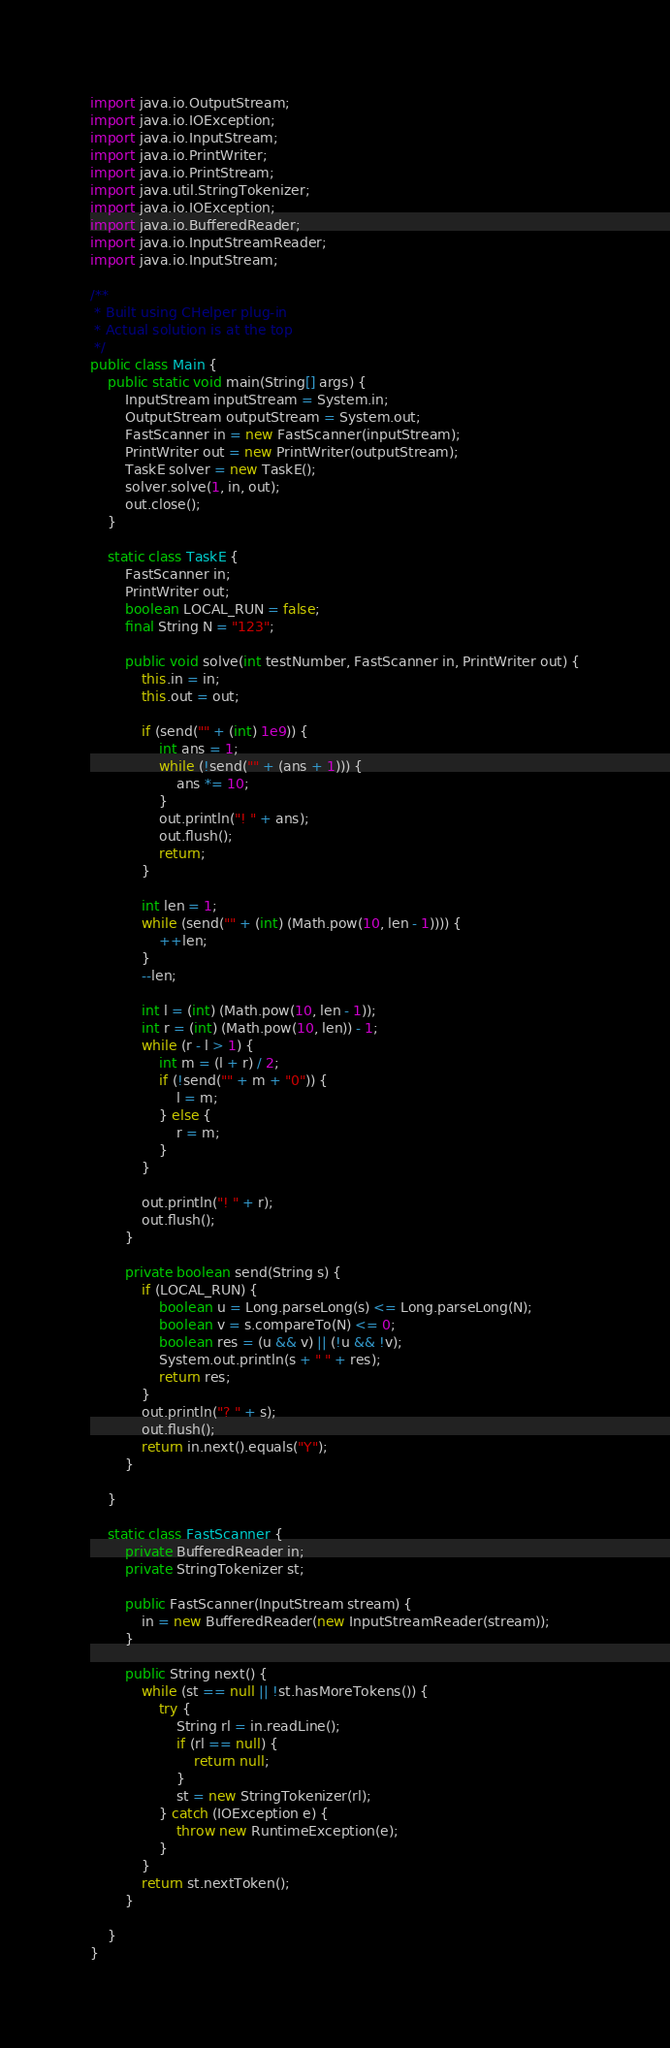<code> <loc_0><loc_0><loc_500><loc_500><_Java_>import java.io.OutputStream;
import java.io.IOException;
import java.io.InputStream;
import java.io.PrintWriter;
import java.io.PrintStream;
import java.util.StringTokenizer;
import java.io.IOException;
import java.io.BufferedReader;
import java.io.InputStreamReader;
import java.io.InputStream;

/**
 * Built using CHelper plug-in
 * Actual solution is at the top
 */
public class Main {
	public static void main(String[] args) {
		InputStream inputStream = System.in;
		OutputStream outputStream = System.out;
		FastScanner in = new FastScanner(inputStream);
		PrintWriter out = new PrintWriter(outputStream);
		TaskE solver = new TaskE();
		solver.solve(1, in, out);
		out.close();
	}

	static class TaskE {
		FastScanner in;
		PrintWriter out;
		boolean LOCAL_RUN = false;
		final String N = "123";

		public void solve(int testNumber, FastScanner in, PrintWriter out) {
			this.in = in;
			this.out = out;

			if (send("" + (int) 1e9)) {
				int ans = 1;
				while (!send("" + (ans + 1))) {
					ans *= 10;
				}
				out.println("! " + ans);
				out.flush();
				return;
			}

			int len = 1;
			while (send("" + (int) (Math.pow(10, len - 1)))) {
				++len;
			}
			--len;

			int l = (int) (Math.pow(10, len - 1));
			int r = (int) (Math.pow(10, len)) - 1;
			while (r - l > 1) {
				int m = (l + r) / 2;
				if (!send("" + m + "0")) {
					l = m;
				} else {
					r = m;
				}
			}

			out.println("! " + r);
			out.flush();
		}

		private boolean send(String s) {
			if (LOCAL_RUN) {
				boolean u = Long.parseLong(s) <= Long.parseLong(N);
				boolean v = s.compareTo(N) <= 0;
				boolean res = (u && v) || (!u && !v);
				System.out.println(s + " " + res);
				return res;
			}
			out.println("? " + s);
			out.flush();
			return in.next().equals("Y");
		}

	}

	static class FastScanner {
		private BufferedReader in;
		private StringTokenizer st;

		public FastScanner(InputStream stream) {
			in = new BufferedReader(new InputStreamReader(stream));
		}

		public String next() {
			while (st == null || !st.hasMoreTokens()) {
				try {
					String rl = in.readLine();
					if (rl == null) {
						return null;
					}
					st = new StringTokenizer(rl);
				} catch (IOException e) {
					throw new RuntimeException(e);
				}
			}
			return st.nextToken();
		}

	}
}

</code> 